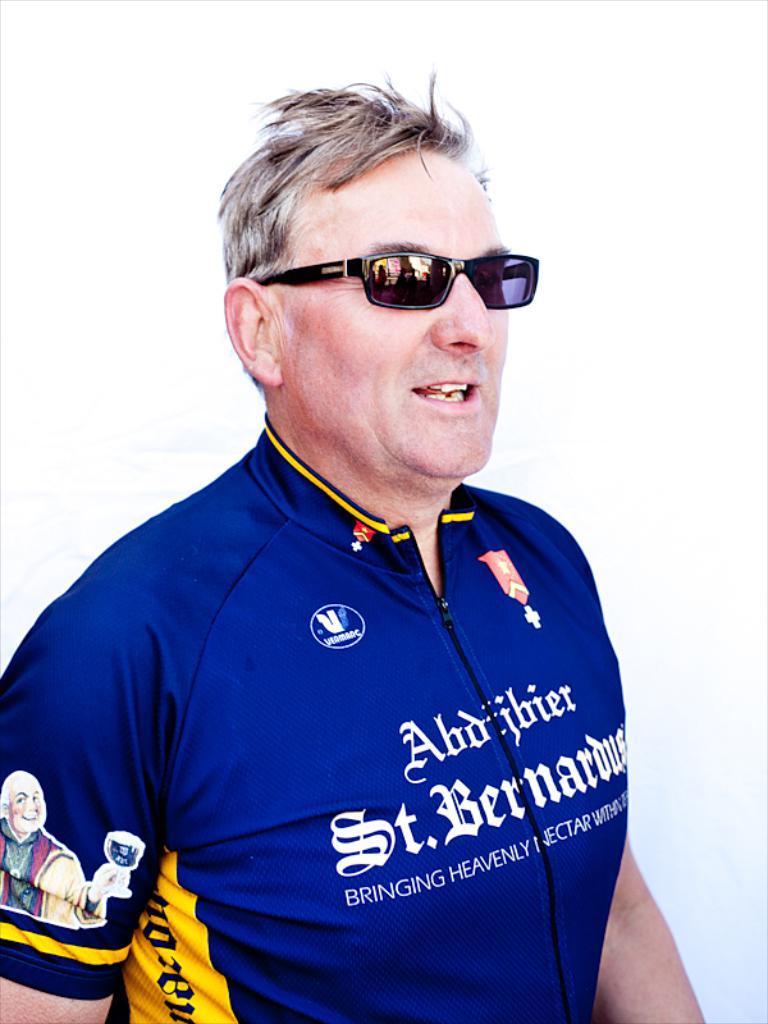What does it say before heavenly?
Make the answer very short. Bringing. What does it say after heavenly?
Your answer should be compact. Nectar. 